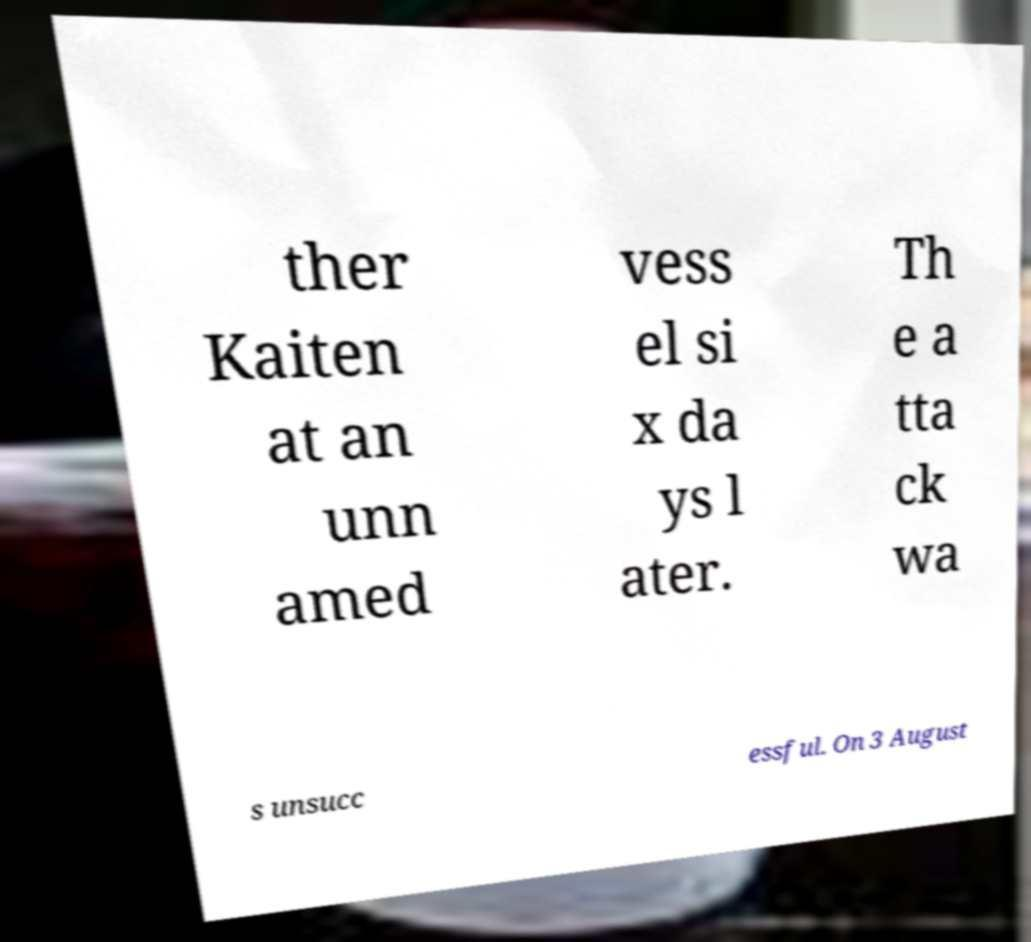There's text embedded in this image that I need extracted. Can you transcribe it verbatim? ther Kaiten at an unn amed vess el si x da ys l ater. Th e a tta ck wa s unsucc essful. On 3 August 